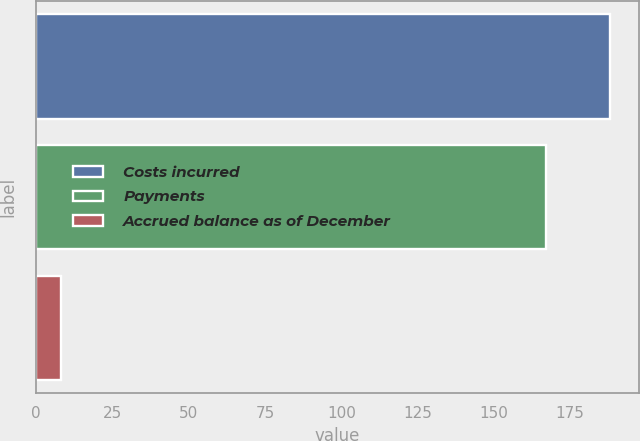Convert chart. <chart><loc_0><loc_0><loc_500><loc_500><bar_chart><fcel>Costs incurred<fcel>Payments<fcel>Accrued balance as of December<nl><fcel>188<fcel>167<fcel>8<nl></chart> 